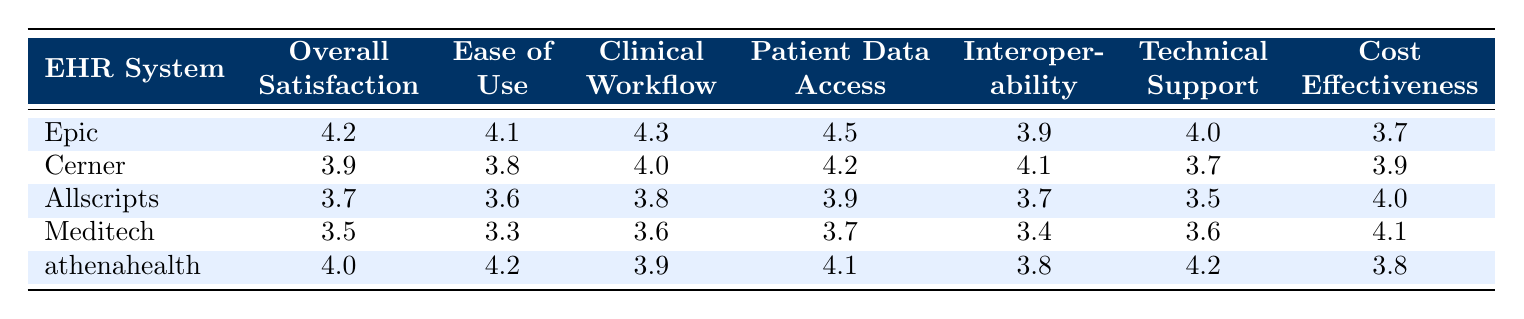What is the Overall Satisfaction Score for Epic? The Overall Satisfaction Score for Epic is directly provided in the table. It is located in the row corresponding to Epic under the Overall Satisfaction Score column. The value listed is 4.2.
Answer: 4.2 Which EHR System has the highest Patient Data Access score? By comparing the Patient Data Access scores from all the EHR Systems listed, Epic has the highest score at 4.5, as seen in its corresponding row.
Answer: Epic What is the average Cost Effectiveness score of all EHR Systems? To calculate the average Cost Effectiveness score, we will sum up the scores: 3.7 (Epic) + 3.9 (Cerner) + 4.0 (Allscripts) + 4.1 (Meditech) + 3.8 (athenahealth) = 19.5. Then, we divide by 5 (the number of systems) which is 19.5 / 5 = 3.9.
Answer: 3.9 Is the Interoperability score for Cerner higher than that of Allscripts? By checking the Interoperability scores in the table, Cerner has a score of 4.1 and Allscripts has a score of 3.7. Since 4.1 is greater than 3.7, the statement is true.
Answer: Yes Which EHR System has the lowest Ease of Use score? The Ease of Use scores for each EHR System are 4.1 (Epic), 3.8 (Cerner), 3.6 (Allscripts), 3.3 (Meditech), and 4.2 (athenahealth). The lowest score is from Meditech, making it the one with the lowest Ease of Use score.
Answer: Meditech What is the difference between the Overall Satisfaction Scores of athenahealth and Meditech? The Overall Satisfaction Score for athenahealth is 4.0, and for Meditech, it is 3.5. The difference is calculated by subtracting Meditech's score from athenahealth's score: 4.0 - 3.5 = 0.5.
Answer: 0.5 Does any EHR System have a Clinical Workflow Integration score above 4.0? Checking through the Clinical Workflow Integration scores, Epic (4.3) and Cerner (4.0) both have scores of 4.0 or higher, which means there are indeed systems with scores above 4.0.
Answer: Yes What is the Technical Support score for the EHR System with the second-highest Overall Satisfaction? The EHR Systems are ranked according to Overall Satisfaction, with Epic (4.2) first, followed by athenahealth (4.0) as the second highest. The Technical Support score for athenahealth is 4.2, derived from its specific row in the table.
Answer: 4.2 How many EHR Systems have a Cost Effectiveness score below 4.0? Evaluating the Cost Effectiveness scores: Epic (3.7), Cerner (3.9), Allscripts (4.0), Meditech (4.1), and athenahealth (3.8). The systems below 4.0 are Epic, Cerner, and athenahealth, totaling three systems.
Answer: 3 